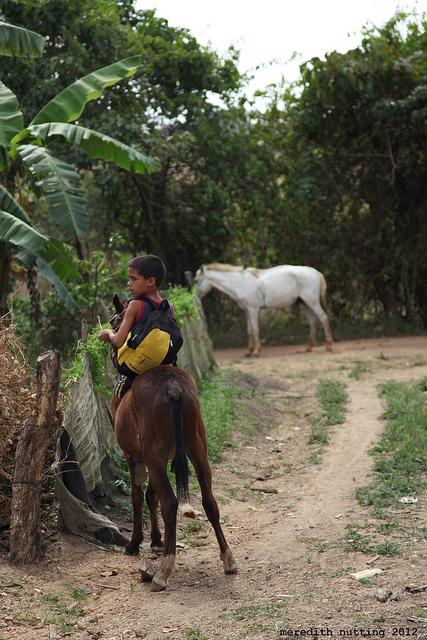Is that a banana tree next to the boy?
Give a very brief answer. Yes. How MANY HORSES ARE THERE IN THE PICTURE?
Short answer required. 2. What color is the horse without a rider?
Concise answer only. White. 